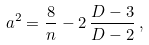Convert formula to latex. <formula><loc_0><loc_0><loc_500><loc_500>a ^ { 2 } = \frac { 8 } { n } - 2 \, \frac { D - 3 } { D - 2 } \, ,</formula> 